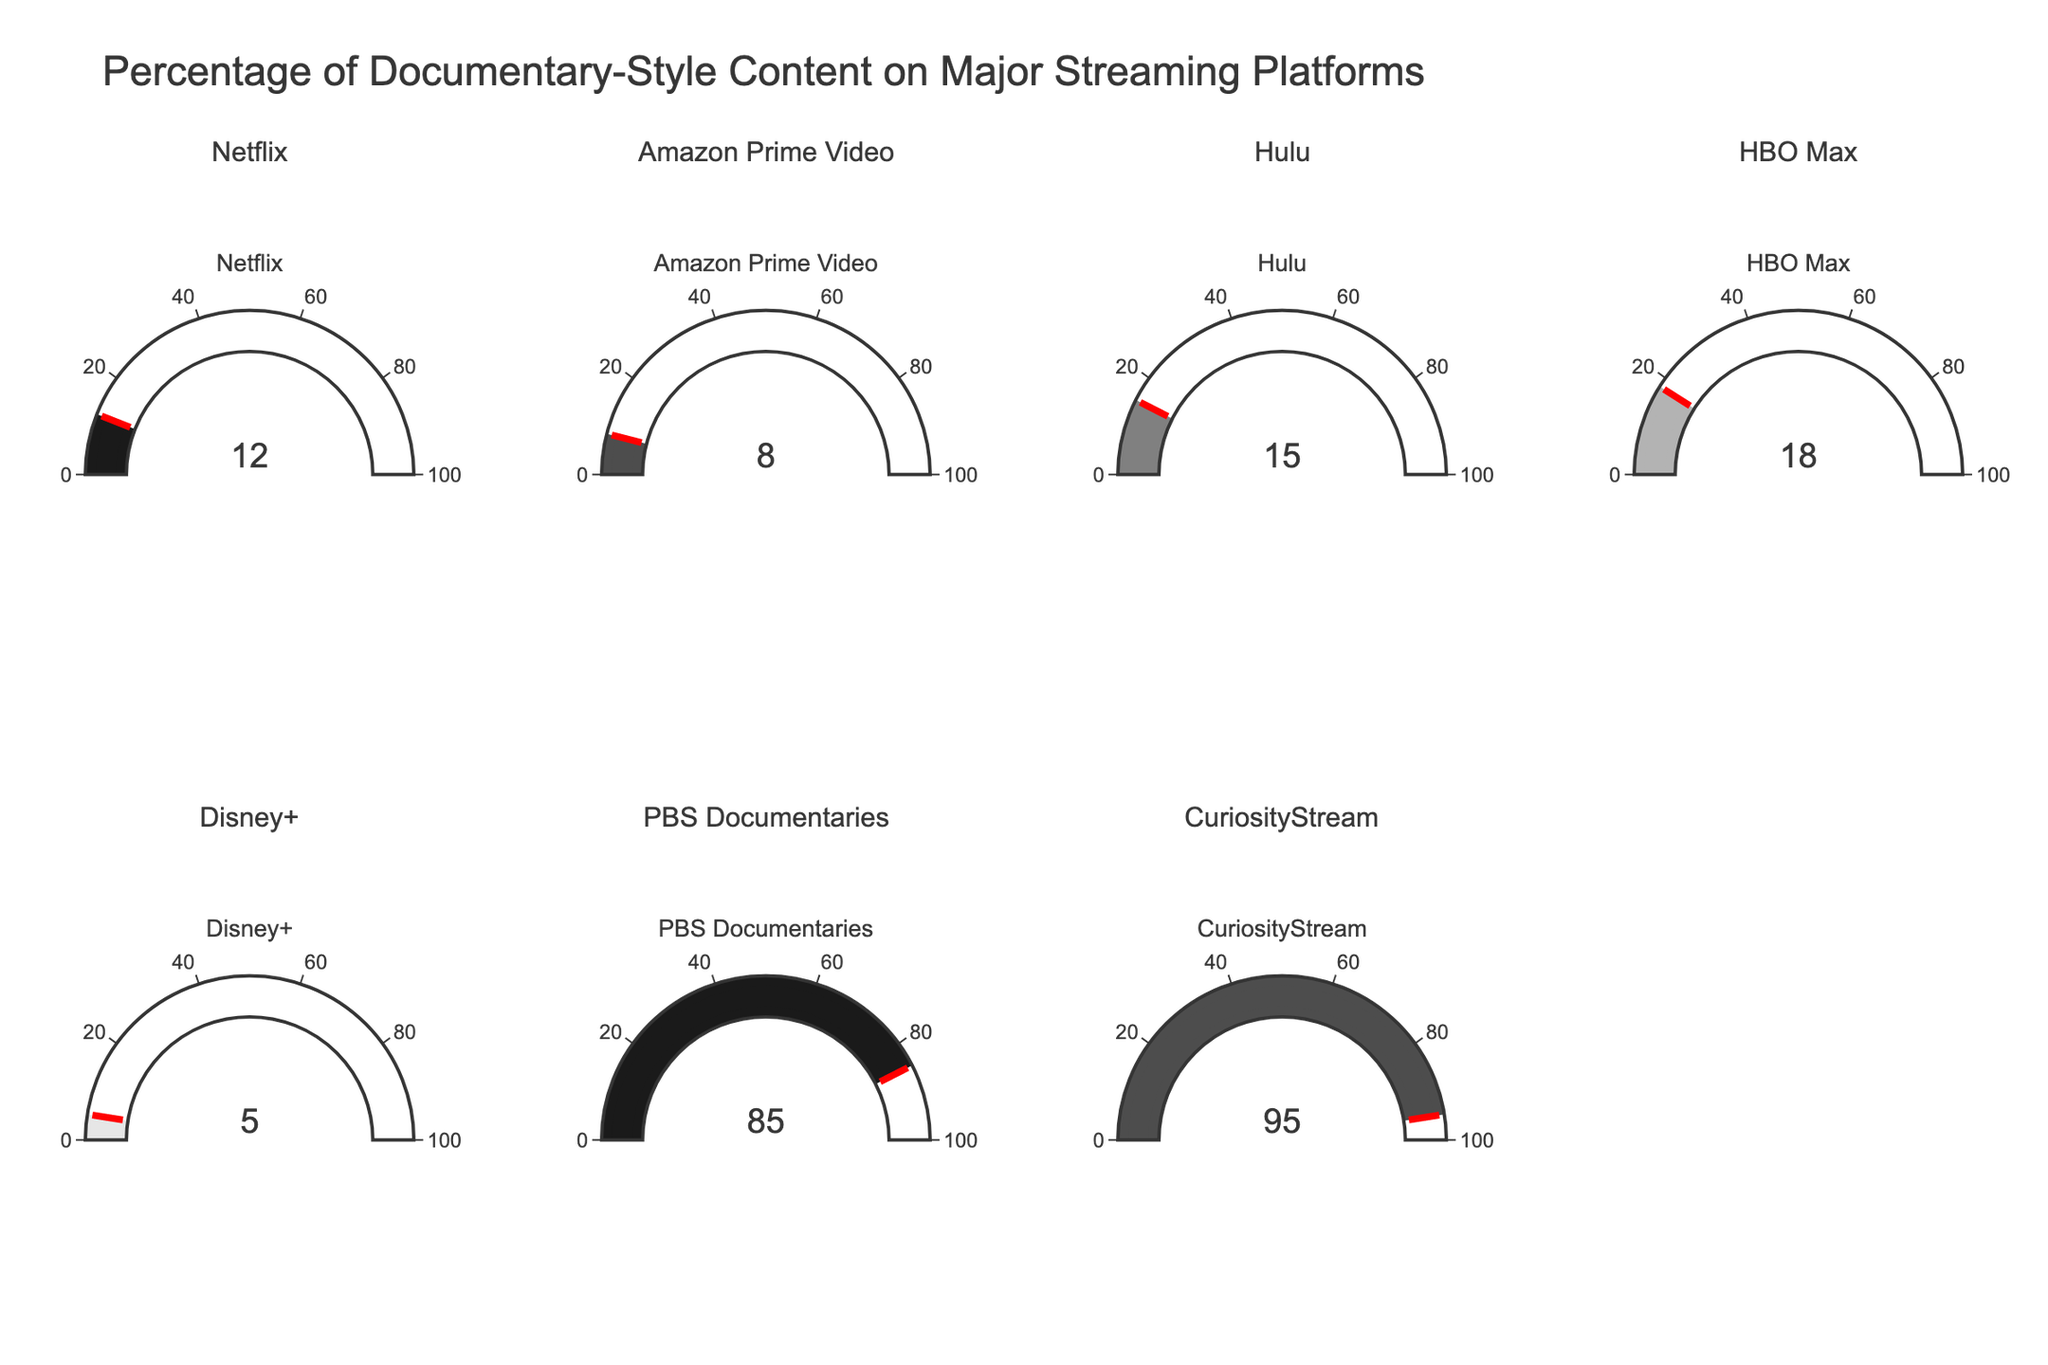Which platform has the highest percentage of documentary-style content? The gauge for CuriosityStream shows the highest value at 95%, indicating it has the highest percentage of documentary-style content among all platforms.
Answer: CuriosityStream What is the gauge value for Netflix? The gauge for Netflix shows a value of 12%, indicating the percentage of documentary-style content on Netflix.
Answer: 12% How many platforms have a documentary content percentage of less than 10%? By checking the gauges, Netflix (12%), Amazon Prime Video (8%), Hulu (15%), HBO Max (18%), Disney+ (5%), PBS Documentaries (85%), and CuriosityStream (95%), only Disney+ (5%) and Amazon Prime Video (8%) are less than 10%.
Answer: 2 Which platform has a higher percentage of documentary-style content, Hulu or HBO Max? Comparing the gauge values, Hulu has 15% and HBO Max has 18%. HBO Max's percentage is higher.
Answer: HBO Max What's the combined percentage of documentary-style content for Netflix and Hulu? Adding the gauge values of Netflix (12%) and Hulu (15%) gives 12 + 15 = 27.
Answer: 27% What is the average percentage of documentary-style content across all platforms? Sum the percentages and divide by the number of platforms: (12 + 8 + 15 + 18 + 5 + 85 + 95) / 7 = 238 / 7 ≈ 34.
Answer: 34 Is the documentary content percentage of Disney+ more than the average percentage? The average percentage is 34%. Disney+ has 5%, which is less than the average.
Answer: No Which platforms have a percentage above 80 but less than 100? Gauges showing 85% and 95% correspond to PBS Documentaries and CuriosityStream, both fall within this range.
Answer: PBS Documentaries, CuriosityStream How many platforms have a documentary content percentage above 20%? According to the gauges, PBS Documentaries (85%) and CuriosityStream (95%) are the only platforms with more than 20%.
Answer: 2 What's the difference in documentary percentage between the platform with the highest value and the one with the lowest? The highest is CuriosityStream at 95%, and the lowest is Disney+ at 5%. The difference is 95 - 5 = 90.
Answer: 90 